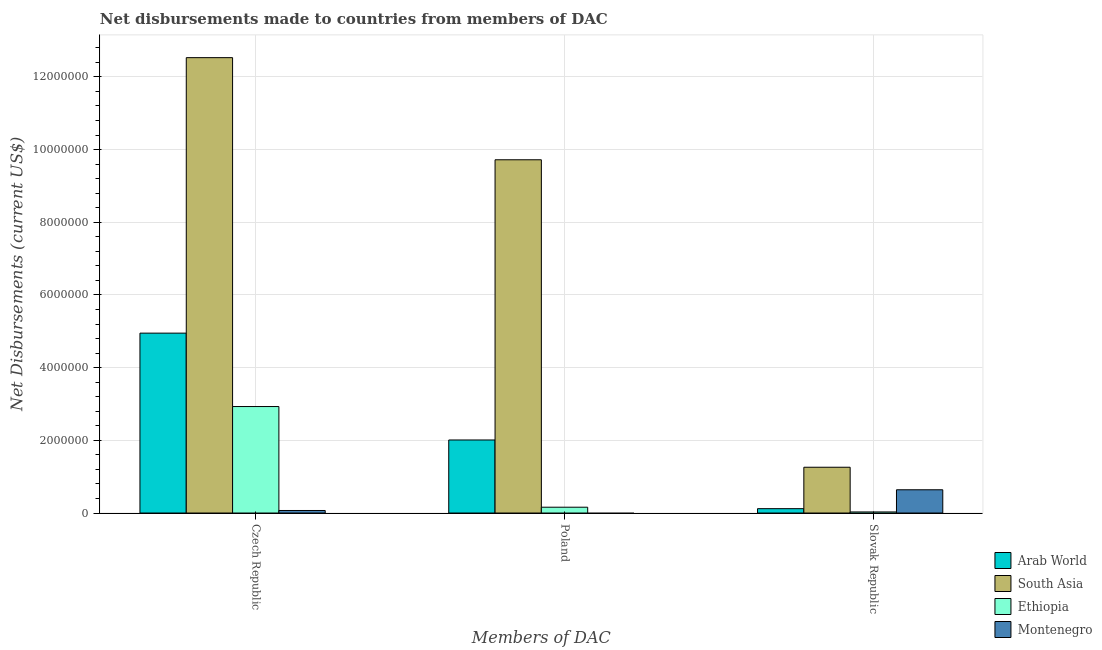How many different coloured bars are there?
Your response must be concise. 4. Are the number of bars per tick equal to the number of legend labels?
Offer a terse response. No. What is the label of the 3rd group of bars from the left?
Offer a terse response. Slovak Republic. What is the net disbursements made by slovak republic in Montenegro?
Your answer should be very brief. 6.40e+05. Across all countries, what is the maximum net disbursements made by czech republic?
Offer a terse response. 1.25e+07. Across all countries, what is the minimum net disbursements made by poland?
Provide a short and direct response. 0. In which country was the net disbursements made by slovak republic maximum?
Offer a terse response. South Asia. What is the total net disbursements made by poland in the graph?
Offer a terse response. 1.19e+07. What is the difference between the net disbursements made by czech republic in Montenegro and that in South Asia?
Your answer should be compact. -1.25e+07. What is the difference between the net disbursements made by czech republic in Montenegro and the net disbursements made by slovak republic in Arab World?
Your answer should be very brief. -5.00e+04. What is the average net disbursements made by czech republic per country?
Provide a succinct answer. 5.12e+06. What is the difference between the net disbursements made by slovak republic and net disbursements made by czech republic in Montenegro?
Offer a very short reply. 5.70e+05. What is the difference between the highest and the second highest net disbursements made by czech republic?
Make the answer very short. 7.58e+06. What is the difference between the highest and the lowest net disbursements made by poland?
Offer a very short reply. 9.72e+06. In how many countries, is the net disbursements made by poland greater than the average net disbursements made by poland taken over all countries?
Provide a short and direct response. 1. Is the sum of the net disbursements made by slovak republic in Arab World and Montenegro greater than the maximum net disbursements made by czech republic across all countries?
Give a very brief answer. No. Is it the case that in every country, the sum of the net disbursements made by czech republic and net disbursements made by poland is greater than the net disbursements made by slovak republic?
Your answer should be very brief. No. Are all the bars in the graph horizontal?
Provide a succinct answer. No. What is the difference between two consecutive major ticks on the Y-axis?
Offer a terse response. 2.00e+06. Are the values on the major ticks of Y-axis written in scientific E-notation?
Your response must be concise. No. Does the graph contain any zero values?
Offer a terse response. Yes. Where does the legend appear in the graph?
Your response must be concise. Bottom right. What is the title of the graph?
Offer a terse response. Net disbursements made to countries from members of DAC. What is the label or title of the X-axis?
Your answer should be very brief. Members of DAC. What is the label or title of the Y-axis?
Provide a short and direct response. Net Disbursements (current US$). What is the Net Disbursements (current US$) in Arab World in Czech Republic?
Ensure brevity in your answer.  4.95e+06. What is the Net Disbursements (current US$) of South Asia in Czech Republic?
Your answer should be very brief. 1.25e+07. What is the Net Disbursements (current US$) of Ethiopia in Czech Republic?
Your answer should be very brief. 2.93e+06. What is the Net Disbursements (current US$) in Montenegro in Czech Republic?
Make the answer very short. 7.00e+04. What is the Net Disbursements (current US$) of Arab World in Poland?
Give a very brief answer. 2.01e+06. What is the Net Disbursements (current US$) in South Asia in Poland?
Offer a terse response. 9.72e+06. What is the Net Disbursements (current US$) in Ethiopia in Poland?
Offer a very short reply. 1.60e+05. What is the Net Disbursements (current US$) in Montenegro in Poland?
Your answer should be compact. 0. What is the Net Disbursements (current US$) of South Asia in Slovak Republic?
Your answer should be compact. 1.26e+06. What is the Net Disbursements (current US$) in Montenegro in Slovak Republic?
Give a very brief answer. 6.40e+05. Across all Members of DAC, what is the maximum Net Disbursements (current US$) in Arab World?
Give a very brief answer. 4.95e+06. Across all Members of DAC, what is the maximum Net Disbursements (current US$) of South Asia?
Offer a terse response. 1.25e+07. Across all Members of DAC, what is the maximum Net Disbursements (current US$) in Ethiopia?
Your answer should be compact. 2.93e+06. Across all Members of DAC, what is the maximum Net Disbursements (current US$) of Montenegro?
Provide a short and direct response. 6.40e+05. Across all Members of DAC, what is the minimum Net Disbursements (current US$) of Arab World?
Your response must be concise. 1.20e+05. Across all Members of DAC, what is the minimum Net Disbursements (current US$) in South Asia?
Make the answer very short. 1.26e+06. Across all Members of DAC, what is the minimum Net Disbursements (current US$) of Ethiopia?
Your answer should be compact. 3.00e+04. What is the total Net Disbursements (current US$) of Arab World in the graph?
Provide a short and direct response. 7.08e+06. What is the total Net Disbursements (current US$) in South Asia in the graph?
Your response must be concise. 2.35e+07. What is the total Net Disbursements (current US$) in Ethiopia in the graph?
Give a very brief answer. 3.12e+06. What is the total Net Disbursements (current US$) in Montenegro in the graph?
Your response must be concise. 7.10e+05. What is the difference between the Net Disbursements (current US$) in Arab World in Czech Republic and that in Poland?
Provide a succinct answer. 2.94e+06. What is the difference between the Net Disbursements (current US$) of South Asia in Czech Republic and that in Poland?
Make the answer very short. 2.81e+06. What is the difference between the Net Disbursements (current US$) in Ethiopia in Czech Republic and that in Poland?
Offer a terse response. 2.77e+06. What is the difference between the Net Disbursements (current US$) in Arab World in Czech Republic and that in Slovak Republic?
Your response must be concise. 4.83e+06. What is the difference between the Net Disbursements (current US$) in South Asia in Czech Republic and that in Slovak Republic?
Offer a terse response. 1.13e+07. What is the difference between the Net Disbursements (current US$) of Ethiopia in Czech Republic and that in Slovak Republic?
Offer a terse response. 2.90e+06. What is the difference between the Net Disbursements (current US$) in Montenegro in Czech Republic and that in Slovak Republic?
Provide a succinct answer. -5.70e+05. What is the difference between the Net Disbursements (current US$) in Arab World in Poland and that in Slovak Republic?
Your response must be concise. 1.89e+06. What is the difference between the Net Disbursements (current US$) of South Asia in Poland and that in Slovak Republic?
Your response must be concise. 8.46e+06. What is the difference between the Net Disbursements (current US$) of Ethiopia in Poland and that in Slovak Republic?
Your answer should be very brief. 1.30e+05. What is the difference between the Net Disbursements (current US$) of Arab World in Czech Republic and the Net Disbursements (current US$) of South Asia in Poland?
Provide a short and direct response. -4.77e+06. What is the difference between the Net Disbursements (current US$) in Arab World in Czech Republic and the Net Disbursements (current US$) in Ethiopia in Poland?
Offer a terse response. 4.79e+06. What is the difference between the Net Disbursements (current US$) in South Asia in Czech Republic and the Net Disbursements (current US$) in Ethiopia in Poland?
Provide a succinct answer. 1.24e+07. What is the difference between the Net Disbursements (current US$) in Arab World in Czech Republic and the Net Disbursements (current US$) in South Asia in Slovak Republic?
Your answer should be compact. 3.69e+06. What is the difference between the Net Disbursements (current US$) of Arab World in Czech Republic and the Net Disbursements (current US$) of Ethiopia in Slovak Republic?
Give a very brief answer. 4.92e+06. What is the difference between the Net Disbursements (current US$) in Arab World in Czech Republic and the Net Disbursements (current US$) in Montenegro in Slovak Republic?
Your answer should be very brief. 4.31e+06. What is the difference between the Net Disbursements (current US$) in South Asia in Czech Republic and the Net Disbursements (current US$) in Ethiopia in Slovak Republic?
Your answer should be very brief. 1.25e+07. What is the difference between the Net Disbursements (current US$) in South Asia in Czech Republic and the Net Disbursements (current US$) in Montenegro in Slovak Republic?
Your response must be concise. 1.19e+07. What is the difference between the Net Disbursements (current US$) in Ethiopia in Czech Republic and the Net Disbursements (current US$) in Montenegro in Slovak Republic?
Make the answer very short. 2.29e+06. What is the difference between the Net Disbursements (current US$) of Arab World in Poland and the Net Disbursements (current US$) of South Asia in Slovak Republic?
Offer a very short reply. 7.50e+05. What is the difference between the Net Disbursements (current US$) in Arab World in Poland and the Net Disbursements (current US$) in Ethiopia in Slovak Republic?
Provide a succinct answer. 1.98e+06. What is the difference between the Net Disbursements (current US$) in Arab World in Poland and the Net Disbursements (current US$) in Montenegro in Slovak Republic?
Ensure brevity in your answer.  1.37e+06. What is the difference between the Net Disbursements (current US$) of South Asia in Poland and the Net Disbursements (current US$) of Ethiopia in Slovak Republic?
Your answer should be very brief. 9.69e+06. What is the difference between the Net Disbursements (current US$) of South Asia in Poland and the Net Disbursements (current US$) of Montenegro in Slovak Republic?
Ensure brevity in your answer.  9.08e+06. What is the difference between the Net Disbursements (current US$) in Ethiopia in Poland and the Net Disbursements (current US$) in Montenegro in Slovak Republic?
Your answer should be very brief. -4.80e+05. What is the average Net Disbursements (current US$) in Arab World per Members of DAC?
Provide a succinct answer. 2.36e+06. What is the average Net Disbursements (current US$) in South Asia per Members of DAC?
Provide a short and direct response. 7.84e+06. What is the average Net Disbursements (current US$) of Ethiopia per Members of DAC?
Give a very brief answer. 1.04e+06. What is the average Net Disbursements (current US$) in Montenegro per Members of DAC?
Keep it short and to the point. 2.37e+05. What is the difference between the Net Disbursements (current US$) of Arab World and Net Disbursements (current US$) of South Asia in Czech Republic?
Make the answer very short. -7.58e+06. What is the difference between the Net Disbursements (current US$) of Arab World and Net Disbursements (current US$) of Ethiopia in Czech Republic?
Keep it short and to the point. 2.02e+06. What is the difference between the Net Disbursements (current US$) in Arab World and Net Disbursements (current US$) in Montenegro in Czech Republic?
Make the answer very short. 4.88e+06. What is the difference between the Net Disbursements (current US$) in South Asia and Net Disbursements (current US$) in Ethiopia in Czech Republic?
Offer a terse response. 9.60e+06. What is the difference between the Net Disbursements (current US$) of South Asia and Net Disbursements (current US$) of Montenegro in Czech Republic?
Your answer should be very brief. 1.25e+07. What is the difference between the Net Disbursements (current US$) in Ethiopia and Net Disbursements (current US$) in Montenegro in Czech Republic?
Your answer should be compact. 2.86e+06. What is the difference between the Net Disbursements (current US$) in Arab World and Net Disbursements (current US$) in South Asia in Poland?
Your answer should be very brief. -7.71e+06. What is the difference between the Net Disbursements (current US$) of Arab World and Net Disbursements (current US$) of Ethiopia in Poland?
Keep it short and to the point. 1.85e+06. What is the difference between the Net Disbursements (current US$) of South Asia and Net Disbursements (current US$) of Ethiopia in Poland?
Make the answer very short. 9.56e+06. What is the difference between the Net Disbursements (current US$) of Arab World and Net Disbursements (current US$) of South Asia in Slovak Republic?
Make the answer very short. -1.14e+06. What is the difference between the Net Disbursements (current US$) of Arab World and Net Disbursements (current US$) of Ethiopia in Slovak Republic?
Your response must be concise. 9.00e+04. What is the difference between the Net Disbursements (current US$) of Arab World and Net Disbursements (current US$) of Montenegro in Slovak Republic?
Your response must be concise. -5.20e+05. What is the difference between the Net Disbursements (current US$) in South Asia and Net Disbursements (current US$) in Ethiopia in Slovak Republic?
Provide a succinct answer. 1.23e+06. What is the difference between the Net Disbursements (current US$) in South Asia and Net Disbursements (current US$) in Montenegro in Slovak Republic?
Your response must be concise. 6.20e+05. What is the difference between the Net Disbursements (current US$) in Ethiopia and Net Disbursements (current US$) in Montenegro in Slovak Republic?
Offer a terse response. -6.10e+05. What is the ratio of the Net Disbursements (current US$) of Arab World in Czech Republic to that in Poland?
Offer a terse response. 2.46. What is the ratio of the Net Disbursements (current US$) of South Asia in Czech Republic to that in Poland?
Your answer should be very brief. 1.29. What is the ratio of the Net Disbursements (current US$) in Ethiopia in Czech Republic to that in Poland?
Offer a very short reply. 18.31. What is the ratio of the Net Disbursements (current US$) in Arab World in Czech Republic to that in Slovak Republic?
Your response must be concise. 41.25. What is the ratio of the Net Disbursements (current US$) in South Asia in Czech Republic to that in Slovak Republic?
Provide a succinct answer. 9.94. What is the ratio of the Net Disbursements (current US$) in Ethiopia in Czech Republic to that in Slovak Republic?
Your answer should be compact. 97.67. What is the ratio of the Net Disbursements (current US$) of Montenegro in Czech Republic to that in Slovak Republic?
Keep it short and to the point. 0.11. What is the ratio of the Net Disbursements (current US$) in Arab World in Poland to that in Slovak Republic?
Keep it short and to the point. 16.75. What is the ratio of the Net Disbursements (current US$) of South Asia in Poland to that in Slovak Republic?
Keep it short and to the point. 7.71. What is the ratio of the Net Disbursements (current US$) in Ethiopia in Poland to that in Slovak Republic?
Offer a very short reply. 5.33. What is the difference between the highest and the second highest Net Disbursements (current US$) of Arab World?
Provide a short and direct response. 2.94e+06. What is the difference between the highest and the second highest Net Disbursements (current US$) in South Asia?
Provide a short and direct response. 2.81e+06. What is the difference between the highest and the second highest Net Disbursements (current US$) in Ethiopia?
Your answer should be compact. 2.77e+06. What is the difference between the highest and the lowest Net Disbursements (current US$) in Arab World?
Give a very brief answer. 4.83e+06. What is the difference between the highest and the lowest Net Disbursements (current US$) of South Asia?
Provide a succinct answer. 1.13e+07. What is the difference between the highest and the lowest Net Disbursements (current US$) in Ethiopia?
Offer a terse response. 2.90e+06. What is the difference between the highest and the lowest Net Disbursements (current US$) of Montenegro?
Give a very brief answer. 6.40e+05. 